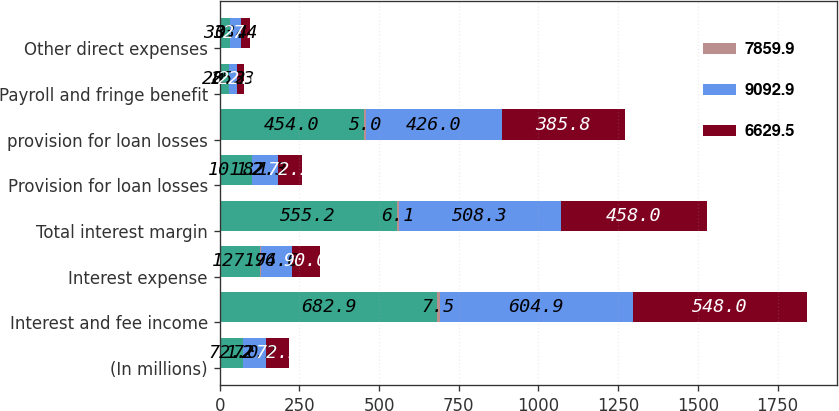Convert chart to OTSL. <chart><loc_0><loc_0><loc_500><loc_500><stacked_bar_chart><ecel><fcel>(In millions)<fcel>Interest and fee income<fcel>Interest expense<fcel>Total interest margin<fcel>Provision for loan losses<fcel>provision for loan losses<fcel>Payroll and fringe benefit<fcel>Other direct expenses<nl><fcel>nan<fcel>72.2<fcel>682.9<fcel>127.7<fcel>555.2<fcel>101.2<fcel>454<fcel>28.2<fcel>33.4<nl><fcel>7859.9<fcel>1<fcel>7.5<fcel>1.4<fcel>6.1<fcel>1.1<fcel>5<fcel>0.3<fcel>0.4<nl><fcel>9092.9<fcel>72.2<fcel>604.9<fcel>96.6<fcel>508.3<fcel>82.3<fcel>426<fcel>25.3<fcel>33.4<nl><fcel>6629.5<fcel>72.2<fcel>548<fcel>90<fcel>458<fcel>72.2<fcel>385.8<fcel>22.6<fcel>27.1<nl></chart> 